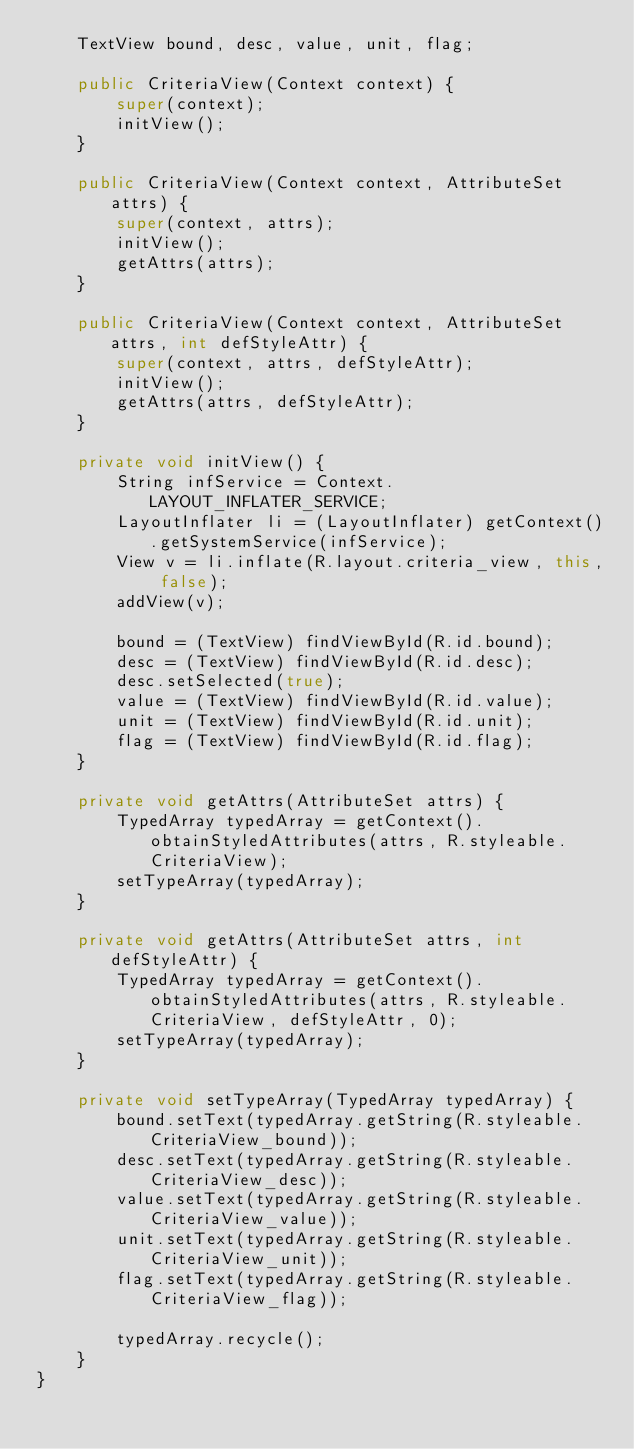<code> <loc_0><loc_0><loc_500><loc_500><_Java_>    TextView bound, desc, value, unit, flag;

    public CriteriaView(Context context) {
        super(context);
        initView();
    }

    public CriteriaView(Context context, AttributeSet attrs) {
        super(context, attrs);
        initView();
        getAttrs(attrs);
    }

    public CriteriaView(Context context, AttributeSet attrs, int defStyleAttr) {
        super(context, attrs, defStyleAttr);
        initView();
        getAttrs(attrs, defStyleAttr);
    }

    private void initView() {
        String infService = Context.LAYOUT_INFLATER_SERVICE;
        LayoutInflater li = (LayoutInflater) getContext().getSystemService(infService);
        View v = li.inflate(R.layout.criteria_view, this, false);
        addView(v);

        bound = (TextView) findViewById(R.id.bound);
        desc = (TextView) findViewById(R.id.desc);
        desc.setSelected(true);
        value = (TextView) findViewById(R.id.value);
        unit = (TextView) findViewById(R.id.unit);
        flag = (TextView) findViewById(R.id.flag);
    }

    private void getAttrs(AttributeSet attrs) {
        TypedArray typedArray = getContext().obtainStyledAttributes(attrs, R.styleable.CriteriaView);
        setTypeArray(typedArray);
    }

    private void getAttrs(AttributeSet attrs, int defStyleAttr) {
        TypedArray typedArray = getContext().obtainStyledAttributes(attrs, R.styleable.CriteriaView, defStyleAttr, 0);
        setTypeArray(typedArray);
    }

    private void setTypeArray(TypedArray typedArray) {
        bound.setText(typedArray.getString(R.styleable.CriteriaView_bound));
        desc.setText(typedArray.getString(R.styleable.CriteriaView_desc));
        value.setText(typedArray.getString(R.styleable.CriteriaView_value));
        unit.setText(typedArray.getString(R.styleable.CriteriaView_unit));
        flag.setText(typedArray.getString(R.styleable.CriteriaView_flag));

        typedArray.recycle();
    }
}
</code> 